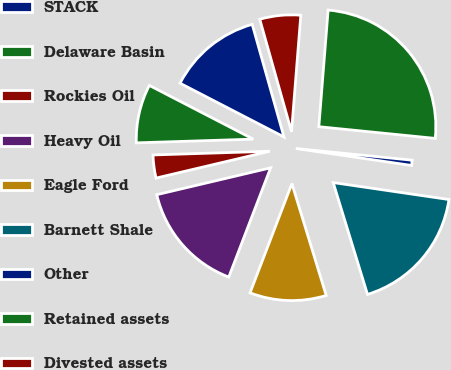<chart> <loc_0><loc_0><loc_500><loc_500><pie_chart><fcel>STACK<fcel>Delaware Basin<fcel>Rockies Oil<fcel>Heavy Oil<fcel>Eagle Ford<fcel>Barnett Shale<fcel>Other<fcel>Retained assets<fcel>Divested assets<nl><fcel>13.03%<fcel>8.1%<fcel>3.18%<fcel>15.49%<fcel>10.56%<fcel>17.95%<fcel>0.72%<fcel>25.33%<fcel>5.64%<nl></chart> 